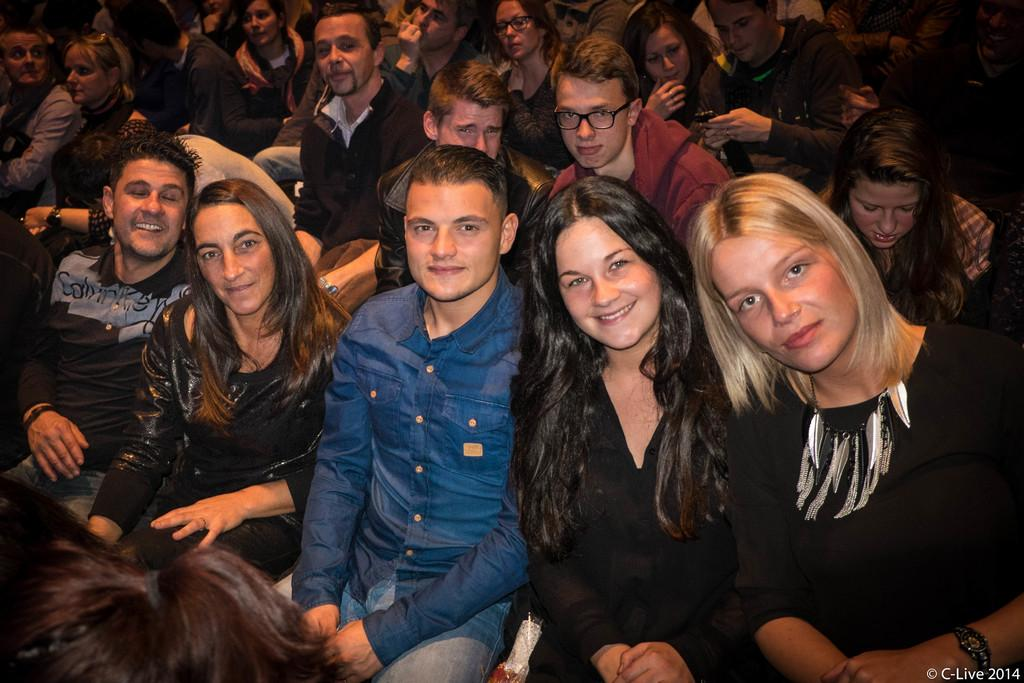What is the main subject of the image? The main subject of the image is a group of people. What are the people in the image doing? The people are seated. Is there any text visible in the image? Yes, there is some text in the bottom right-hand corner of the image. How many people are balancing on a tightrope in the image? There is no tightrope or people balancing on one in the image. What type of camp can be seen in the top left corner of the image? There is no camp present in the image. 